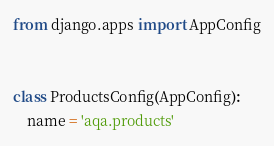Convert code to text. <code><loc_0><loc_0><loc_500><loc_500><_Python_>from django.apps import AppConfig


class ProductsConfig(AppConfig):
    name = 'aqa.products'
</code> 